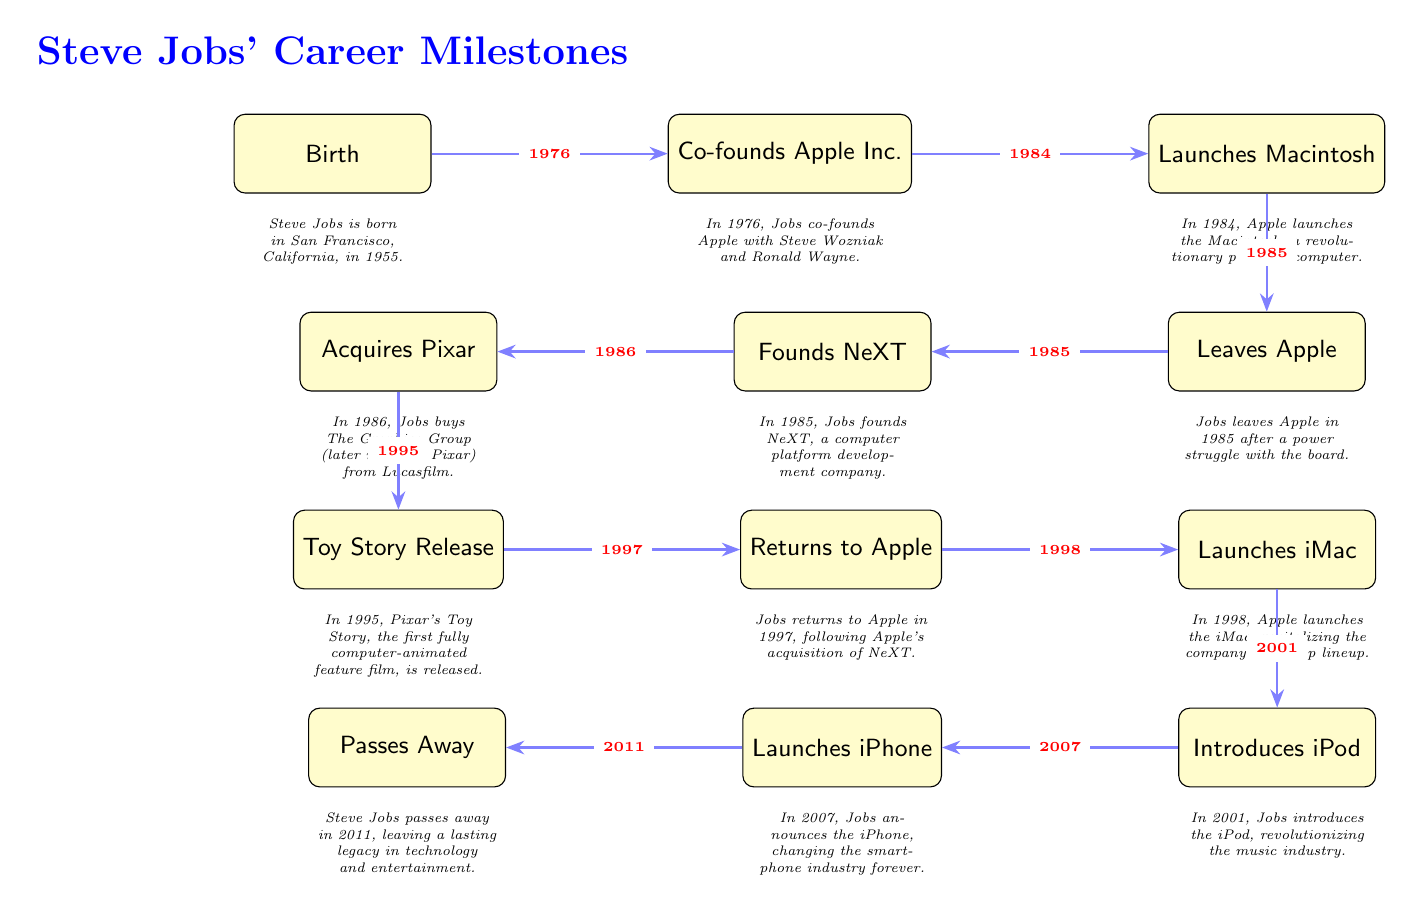What was the year Steve Jobs co-founded Apple Inc.? In the diagram, the arrow leading from the node "Birth" to "Co-founds Apple Inc." is labeled with the year 1976.
Answer: 1976 What event follows the launch of the Macintosh? The diagram shows that the event "Launches Macintosh" is connected to "Leaves Apple" with an arrow. The order indicates "Leaves Apple" occurs after "Launches Macintosh."
Answer: Leaves Apple What major company did Steve Jobs acquire in 1986? The diagram lists the event "Acquires Pixar" under the node "Founds NeXT" with the year 1986. This indicates that the acquisition of Pixar took place in that year.
Answer: Pixar How many major career milestones are detailed in the diagram? By counting the event nodes in the diagram, there are a total of 12 events representing significant milestones in Steve Jobs' career.
Answer: 12 What major product was introduced right before the launch of the iPhone? Analyzing the diagram, the node "Introduces iPod" comes directly before the node "Launches iPhone," indicating that the iPod was launched right before the iPhone.
Answer: Introduces iPod In what year did Steve Jobs pass away? The diagram indicates the last event, "Passes Away," is connected to the year 2011. Hence, the year of Steve Jobs' passing is clearly stated there.
Answer: 2011 What is the first event shown in the diagram? The very first node in the diagram is labeled "Birth," indicating that this is the starting point of Steve Jobs' career milestones.
Answer: Birth Which event directly follows the acquisition of Pixar? According to the flow of the diagram, "Toy Story Release" follows "Acquires Pixar," showing the timeline of events.
Answer: Toy Story Release What was the significant impact of the iPod launch according to its event description? The description under "Introduces iPod" states that it revolutionized the music industry, indicating the significant impact of the iPod launch on that sector.
Answer: Revolutionizing the music industry 